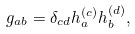<formula> <loc_0><loc_0><loc_500><loc_500>g _ { a b } = \delta _ { c d } h _ { a } ^ { ( c ) } h _ { b } ^ { ( d ) } ,</formula> 